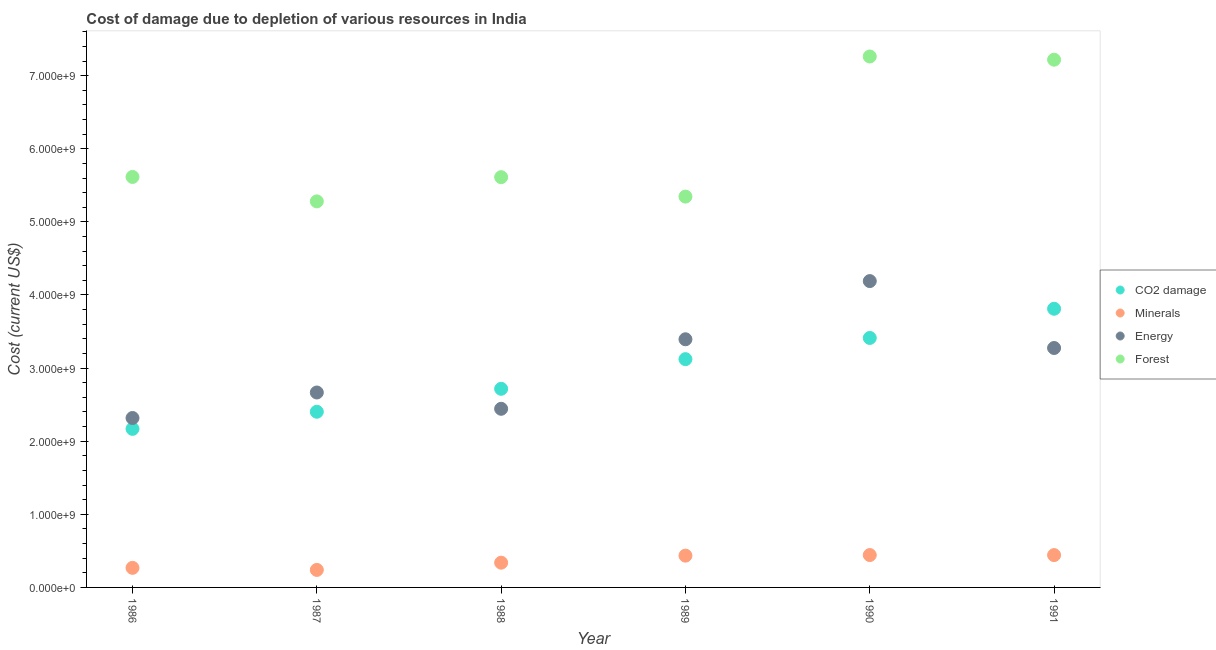What is the cost of damage due to depletion of coal in 1991?
Provide a short and direct response. 3.81e+09. Across all years, what is the maximum cost of damage due to depletion of coal?
Make the answer very short. 3.81e+09. Across all years, what is the minimum cost of damage due to depletion of forests?
Make the answer very short. 5.28e+09. In which year was the cost of damage due to depletion of coal minimum?
Make the answer very short. 1986. What is the total cost of damage due to depletion of energy in the graph?
Ensure brevity in your answer.  1.83e+1. What is the difference between the cost of damage due to depletion of forests in 1986 and that in 1991?
Keep it short and to the point. -1.60e+09. What is the difference between the cost of damage due to depletion of forests in 1988 and the cost of damage due to depletion of energy in 1986?
Your answer should be compact. 3.29e+09. What is the average cost of damage due to depletion of forests per year?
Provide a succinct answer. 6.06e+09. In the year 1991, what is the difference between the cost of damage due to depletion of forests and cost of damage due to depletion of minerals?
Make the answer very short. 6.78e+09. What is the ratio of the cost of damage due to depletion of forests in 1986 to that in 1990?
Provide a short and direct response. 0.77. What is the difference between the highest and the second highest cost of damage due to depletion of coal?
Offer a very short reply. 3.99e+08. What is the difference between the highest and the lowest cost of damage due to depletion of coal?
Provide a succinct answer. 1.64e+09. Is the sum of the cost of damage due to depletion of energy in 1987 and 1991 greater than the maximum cost of damage due to depletion of forests across all years?
Your answer should be compact. No. Is it the case that in every year, the sum of the cost of damage due to depletion of coal and cost of damage due to depletion of energy is greater than the sum of cost of damage due to depletion of minerals and cost of damage due to depletion of forests?
Provide a short and direct response. Yes. Does the cost of damage due to depletion of minerals monotonically increase over the years?
Give a very brief answer. No. How many years are there in the graph?
Ensure brevity in your answer.  6. What is the difference between two consecutive major ticks on the Y-axis?
Offer a terse response. 1.00e+09. Does the graph contain grids?
Provide a short and direct response. No. Where does the legend appear in the graph?
Offer a terse response. Center right. What is the title of the graph?
Ensure brevity in your answer.  Cost of damage due to depletion of various resources in India . Does "Miscellaneous expenses" appear as one of the legend labels in the graph?
Your response must be concise. No. What is the label or title of the Y-axis?
Provide a succinct answer. Cost (current US$). What is the Cost (current US$) of CO2 damage in 1986?
Your answer should be compact. 2.17e+09. What is the Cost (current US$) of Minerals in 1986?
Your answer should be very brief. 2.68e+08. What is the Cost (current US$) of Energy in 1986?
Make the answer very short. 2.32e+09. What is the Cost (current US$) in Forest in 1986?
Ensure brevity in your answer.  5.61e+09. What is the Cost (current US$) of CO2 damage in 1987?
Make the answer very short. 2.40e+09. What is the Cost (current US$) in Minerals in 1987?
Your answer should be compact. 2.40e+08. What is the Cost (current US$) of Energy in 1987?
Offer a very short reply. 2.67e+09. What is the Cost (current US$) in Forest in 1987?
Your response must be concise. 5.28e+09. What is the Cost (current US$) in CO2 damage in 1988?
Offer a very short reply. 2.72e+09. What is the Cost (current US$) of Minerals in 1988?
Ensure brevity in your answer.  3.38e+08. What is the Cost (current US$) in Energy in 1988?
Give a very brief answer. 2.44e+09. What is the Cost (current US$) of Forest in 1988?
Provide a short and direct response. 5.61e+09. What is the Cost (current US$) of CO2 damage in 1989?
Offer a very short reply. 3.12e+09. What is the Cost (current US$) of Minerals in 1989?
Offer a terse response. 4.35e+08. What is the Cost (current US$) of Energy in 1989?
Provide a short and direct response. 3.39e+09. What is the Cost (current US$) in Forest in 1989?
Give a very brief answer. 5.35e+09. What is the Cost (current US$) of CO2 damage in 1990?
Your response must be concise. 3.41e+09. What is the Cost (current US$) of Minerals in 1990?
Make the answer very short. 4.43e+08. What is the Cost (current US$) in Energy in 1990?
Provide a short and direct response. 4.19e+09. What is the Cost (current US$) in Forest in 1990?
Offer a terse response. 7.26e+09. What is the Cost (current US$) in CO2 damage in 1991?
Provide a succinct answer. 3.81e+09. What is the Cost (current US$) in Minerals in 1991?
Give a very brief answer. 4.42e+08. What is the Cost (current US$) of Energy in 1991?
Ensure brevity in your answer.  3.27e+09. What is the Cost (current US$) of Forest in 1991?
Provide a succinct answer. 7.22e+09. Across all years, what is the maximum Cost (current US$) of CO2 damage?
Keep it short and to the point. 3.81e+09. Across all years, what is the maximum Cost (current US$) of Minerals?
Offer a very short reply. 4.43e+08. Across all years, what is the maximum Cost (current US$) of Energy?
Your answer should be very brief. 4.19e+09. Across all years, what is the maximum Cost (current US$) of Forest?
Give a very brief answer. 7.26e+09. Across all years, what is the minimum Cost (current US$) of CO2 damage?
Make the answer very short. 2.17e+09. Across all years, what is the minimum Cost (current US$) of Minerals?
Offer a terse response. 2.40e+08. Across all years, what is the minimum Cost (current US$) in Energy?
Provide a short and direct response. 2.32e+09. Across all years, what is the minimum Cost (current US$) of Forest?
Your response must be concise. 5.28e+09. What is the total Cost (current US$) in CO2 damage in the graph?
Your answer should be compact. 1.76e+1. What is the total Cost (current US$) in Minerals in the graph?
Keep it short and to the point. 2.17e+09. What is the total Cost (current US$) in Energy in the graph?
Provide a short and direct response. 1.83e+1. What is the total Cost (current US$) in Forest in the graph?
Provide a short and direct response. 3.63e+1. What is the difference between the Cost (current US$) in CO2 damage in 1986 and that in 1987?
Give a very brief answer. -2.34e+08. What is the difference between the Cost (current US$) in Minerals in 1986 and that in 1987?
Provide a short and direct response. 2.81e+07. What is the difference between the Cost (current US$) in Energy in 1986 and that in 1987?
Keep it short and to the point. -3.49e+08. What is the difference between the Cost (current US$) in Forest in 1986 and that in 1987?
Offer a terse response. 3.34e+08. What is the difference between the Cost (current US$) of CO2 damage in 1986 and that in 1988?
Offer a very short reply. -5.48e+08. What is the difference between the Cost (current US$) of Minerals in 1986 and that in 1988?
Keep it short and to the point. -7.08e+07. What is the difference between the Cost (current US$) in Energy in 1986 and that in 1988?
Keep it short and to the point. -1.26e+08. What is the difference between the Cost (current US$) in Forest in 1986 and that in 1988?
Offer a very short reply. 2.98e+06. What is the difference between the Cost (current US$) in CO2 damage in 1986 and that in 1989?
Provide a succinct answer. -9.54e+08. What is the difference between the Cost (current US$) of Minerals in 1986 and that in 1989?
Give a very brief answer. -1.67e+08. What is the difference between the Cost (current US$) in Energy in 1986 and that in 1989?
Provide a succinct answer. -1.08e+09. What is the difference between the Cost (current US$) of Forest in 1986 and that in 1989?
Ensure brevity in your answer.  2.69e+08. What is the difference between the Cost (current US$) of CO2 damage in 1986 and that in 1990?
Your answer should be compact. -1.24e+09. What is the difference between the Cost (current US$) of Minerals in 1986 and that in 1990?
Offer a terse response. -1.75e+08. What is the difference between the Cost (current US$) of Energy in 1986 and that in 1990?
Give a very brief answer. -1.87e+09. What is the difference between the Cost (current US$) in Forest in 1986 and that in 1990?
Your answer should be compact. -1.65e+09. What is the difference between the Cost (current US$) of CO2 damage in 1986 and that in 1991?
Offer a terse response. -1.64e+09. What is the difference between the Cost (current US$) in Minerals in 1986 and that in 1991?
Offer a very short reply. -1.75e+08. What is the difference between the Cost (current US$) of Energy in 1986 and that in 1991?
Ensure brevity in your answer.  -9.57e+08. What is the difference between the Cost (current US$) of Forest in 1986 and that in 1991?
Your response must be concise. -1.60e+09. What is the difference between the Cost (current US$) of CO2 damage in 1987 and that in 1988?
Make the answer very short. -3.14e+08. What is the difference between the Cost (current US$) of Minerals in 1987 and that in 1988?
Your answer should be very brief. -9.89e+07. What is the difference between the Cost (current US$) of Energy in 1987 and that in 1988?
Provide a succinct answer. 2.23e+08. What is the difference between the Cost (current US$) in Forest in 1987 and that in 1988?
Your answer should be compact. -3.31e+08. What is the difference between the Cost (current US$) in CO2 damage in 1987 and that in 1989?
Give a very brief answer. -7.19e+08. What is the difference between the Cost (current US$) in Minerals in 1987 and that in 1989?
Your answer should be very brief. -1.95e+08. What is the difference between the Cost (current US$) of Energy in 1987 and that in 1989?
Provide a short and direct response. -7.28e+08. What is the difference between the Cost (current US$) of Forest in 1987 and that in 1989?
Your answer should be very brief. -6.53e+07. What is the difference between the Cost (current US$) of CO2 damage in 1987 and that in 1990?
Offer a terse response. -1.01e+09. What is the difference between the Cost (current US$) in Minerals in 1987 and that in 1990?
Provide a short and direct response. -2.03e+08. What is the difference between the Cost (current US$) of Energy in 1987 and that in 1990?
Your response must be concise. -1.52e+09. What is the difference between the Cost (current US$) in Forest in 1987 and that in 1990?
Offer a terse response. -1.98e+09. What is the difference between the Cost (current US$) of CO2 damage in 1987 and that in 1991?
Give a very brief answer. -1.41e+09. What is the difference between the Cost (current US$) in Minerals in 1987 and that in 1991?
Your answer should be very brief. -2.03e+08. What is the difference between the Cost (current US$) in Energy in 1987 and that in 1991?
Your response must be concise. -6.09e+08. What is the difference between the Cost (current US$) in Forest in 1987 and that in 1991?
Offer a terse response. -1.94e+09. What is the difference between the Cost (current US$) of CO2 damage in 1988 and that in 1989?
Your answer should be compact. -4.06e+08. What is the difference between the Cost (current US$) in Minerals in 1988 and that in 1989?
Provide a short and direct response. -9.62e+07. What is the difference between the Cost (current US$) in Energy in 1988 and that in 1989?
Offer a terse response. -9.51e+08. What is the difference between the Cost (current US$) of Forest in 1988 and that in 1989?
Your response must be concise. 2.66e+08. What is the difference between the Cost (current US$) in CO2 damage in 1988 and that in 1990?
Ensure brevity in your answer.  -6.96e+08. What is the difference between the Cost (current US$) of Minerals in 1988 and that in 1990?
Offer a terse response. -1.04e+08. What is the difference between the Cost (current US$) of Energy in 1988 and that in 1990?
Make the answer very short. -1.75e+09. What is the difference between the Cost (current US$) of Forest in 1988 and that in 1990?
Your answer should be compact. -1.65e+09. What is the difference between the Cost (current US$) in CO2 damage in 1988 and that in 1991?
Give a very brief answer. -1.09e+09. What is the difference between the Cost (current US$) of Minerals in 1988 and that in 1991?
Make the answer very short. -1.04e+08. What is the difference between the Cost (current US$) of Energy in 1988 and that in 1991?
Provide a short and direct response. -8.32e+08. What is the difference between the Cost (current US$) in Forest in 1988 and that in 1991?
Ensure brevity in your answer.  -1.61e+09. What is the difference between the Cost (current US$) of CO2 damage in 1989 and that in 1990?
Keep it short and to the point. -2.90e+08. What is the difference between the Cost (current US$) in Minerals in 1989 and that in 1990?
Your response must be concise. -8.24e+06. What is the difference between the Cost (current US$) of Energy in 1989 and that in 1990?
Your response must be concise. -7.96e+08. What is the difference between the Cost (current US$) of Forest in 1989 and that in 1990?
Your answer should be compact. -1.92e+09. What is the difference between the Cost (current US$) in CO2 damage in 1989 and that in 1991?
Your answer should be compact. -6.89e+08. What is the difference between the Cost (current US$) of Minerals in 1989 and that in 1991?
Give a very brief answer. -7.56e+06. What is the difference between the Cost (current US$) of Energy in 1989 and that in 1991?
Keep it short and to the point. 1.19e+08. What is the difference between the Cost (current US$) in Forest in 1989 and that in 1991?
Your response must be concise. -1.87e+09. What is the difference between the Cost (current US$) of CO2 damage in 1990 and that in 1991?
Give a very brief answer. -3.99e+08. What is the difference between the Cost (current US$) of Minerals in 1990 and that in 1991?
Your answer should be very brief. 6.78e+05. What is the difference between the Cost (current US$) in Energy in 1990 and that in 1991?
Your answer should be very brief. 9.15e+08. What is the difference between the Cost (current US$) in Forest in 1990 and that in 1991?
Ensure brevity in your answer.  4.38e+07. What is the difference between the Cost (current US$) of CO2 damage in 1986 and the Cost (current US$) of Minerals in 1987?
Make the answer very short. 1.93e+09. What is the difference between the Cost (current US$) of CO2 damage in 1986 and the Cost (current US$) of Energy in 1987?
Your response must be concise. -4.97e+08. What is the difference between the Cost (current US$) of CO2 damage in 1986 and the Cost (current US$) of Forest in 1987?
Your response must be concise. -3.11e+09. What is the difference between the Cost (current US$) of Minerals in 1986 and the Cost (current US$) of Energy in 1987?
Provide a succinct answer. -2.40e+09. What is the difference between the Cost (current US$) in Minerals in 1986 and the Cost (current US$) in Forest in 1987?
Give a very brief answer. -5.01e+09. What is the difference between the Cost (current US$) of Energy in 1986 and the Cost (current US$) of Forest in 1987?
Your answer should be very brief. -2.96e+09. What is the difference between the Cost (current US$) of CO2 damage in 1986 and the Cost (current US$) of Minerals in 1988?
Your answer should be very brief. 1.83e+09. What is the difference between the Cost (current US$) in CO2 damage in 1986 and the Cost (current US$) in Energy in 1988?
Give a very brief answer. -2.75e+08. What is the difference between the Cost (current US$) in CO2 damage in 1986 and the Cost (current US$) in Forest in 1988?
Your response must be concise. -3.44e+09. What is the difference between the Cost (current US$) of Minerals in 1986 and the Cost (current US$) of Energy in 1988?
Your answer should be compact. -2.18e+09. What is the difference between the Cost (current US$) in Minerals in 1986 and the Cost (current US$) in Forest in 1988?
Offer a very short reply. -5.34e+09. What is the difference between the Cost (current US$) of Energy in 1986 and the Cost (current US$) of Forest in 1988?
Your answer should be compact. -3.29e+09. What is the difference between the Cost (current US$) of CO2 damage in 1986 and the Cost (current US$) of Minerals in 1989?
Provide a succinct answer. 1.73e+09. What is the difference between the Cost (current US$) of CO2 damage in 1986 and the Cost (current US$) of Energy in 1989?
Provide a short and direct response. -1.23e+09. What is the difference between the Cost (current US$) of CO2 damage in 1986 and the Cost (current US$) of Forest in 1989?
Offer a terse response. -3.18e+09. What is the difference between the Cost (current US$) of Minerals in 1986 and the Cost (current US$) of Energy in 1989?
Your answer should be compact. -3.13e+09. What is the difference between the Cost (current US$) in Minerals in 1986 and the Cost (current US$) in Forest in 1989?
Your answer should be very brief. -5.08e+09. What is the difference between the Cost (current US$) in Energy in 1986 and the Cost (current US$) in Forest in 1989?
Your response must be concise. -3.03e+09. What is the difference between the Cost (current US$) in CO2 damage in 1986 and the Cost (current US$) in Minerals in 1990?
Your answer should be compact. 1.73e+09. What is the difference between the Cost (current US$) in CO2 damage in 1986 and the Cost (current US$) in Energy in 1990?
Offer a very short reply. -2.02e+09. What is the difference between the Cost (current US$) in CO2 damage in 1986 and the Cost (current US$) in Forest in 1990?
Offer a terse response. -5.09e+09. What is the difference between the Cost (current US$) in Minerals in 1986 and the Cost (current US$) in Energy in 1990?
Ensure brevity in your answer.  -3.92e+09. What is the difference between the Cost (current US$) of Minerals in 1986 and the Cost (current US$) of Forest in 1990?
Your answer should be very brief. -6.99e+09. What is the difference between the Cost (current US$) in Energy in 1986 and the Cost (current US$) in Forest in 1990?
Offer a very short reply. -4.94e+09. What is the difference between the Cost (current US$) in CO2 damage in 1986 and the Cost (current US$) in Minerals in 1991?
Provide a short and direct response. 1.73e+09. What is the difference between the Cost (current US$) of CO2 damage in 1986 and the Cost (current US$) of Energy in 1991?
Provide a short and direct response. -1.11e+09. What is the difference between the Cost (current US$) in CO2 damage in 1986 and the Cost (current US$) in Forest in 1991?
Provide a short and direct response. -5.05e+09. What is the difference between the Cost (current US$) in Minerals in 1986 and the Cost (current US$) in Energy in 1991?
Make the answer very short. -3.01e+09. What is the difference between the Cost (current US$) in Minerals in 1986 and the Cost (current US$) in Forest in 1991?
Make the answer very short. -6.95e+09. What is the difference between the Cost (current US$) in Energy in 1986 and the Cost (current US$) in Forest in 1991?
Your response must be concise. -4.90e+09. What is the difference between the Cost (current US$) in CO2 damage in 1987 and the Cost (current US$) in Minerals in 1988?
Your answer should be compact. 2.06e+09. What is the difference between the Cost (current US$) of CO2 damage in 1987 and the Cost (current US$) of Energy in 1988?
Provide a succinct answer. -4.05e+07. What is the difference between the Cost (current US$) in CO2 damage in 1987 and the Cost (current US$) in Forest in 1988?
Keep it short and to the point. -3.21e+09. What is the difference between the Cost (current US$) of Minerals in 1987 and the Cost (current US$) of Energy in 1988?
Give a very brief answer. -2.20e+09. What is the difference between the Cost (current US$) in Minerals in 1987 and the Cost (current US$) in Forest in 1988?
Provide a short and direct response. -5.37e+09. What is the difference between the Cost (current US$) of Energy in 1987 and the Cost (current US$) of Forest in 1988?
Your answer should be very brief. -2.95e+09. What is the difference between the Cost (current US$) of CO2 damage in 1987 and the Cost (current US$) of Minerals in 1989?
Provide a succinct answer. 1.97e+09. What is the difference between the Cost (current US$) in CO2 damage in 1987 and the Cost (current US$) in Energy in 1989?
Keep it short and to the point. -9.91e+08. What is the difference between the Cost (current US$) in CO2 damage in 1987 and the Cost (current US$) in Forest in 1989?
Offer a very short reply. -2.94e+09. What is the difference between the Cost (current US$) of Minerals in 1987 and the Cost (current US$) of Energy in 1989?
Offer a terse response. -3.15e+09. What is the difference between the Cost (current US$) of Minerals in 1987 and the Cost (current US$) of Forest in 1989?
Ensure brevity in your answer.  -5.11e+09. What is the difference between the Cost (current US$) of Energy in 1987 and the Cost (current US$) of Forest in 1989?
Provide a succinct answer. -2.68e+09. What is the difference between the Cost (current US$) of CO2 damage in 1987 and the Cost (current US$) of Minerals in 1990?
Give a very brief answer. 1.96e+09. What is the difference between the Cost (current US$) in CO2 damage in 1987 and the Cost (current US$) in Energy in 1990?
Your answer should be compact. -1.79e+09. What is the difference between the Cost (current US$) of CO2 damage in 1987 and the Cost (current US$) of Forest in 1990?
Provide a short and direct response. -4.86e+09. What is the difference between the Cost (current US$) of Minerals in 1987 and the Cost (current US$) of Energy in 1990?
Make the answer very short. -3.95e+09. What is the difference between the Cost (current US$) in Minerals in 1987 and the Cost (current US$) in Forest in 1990?
Make the answer very short. -7.02e+09. What is the difference between the Cost (current US$) in Energy in 1987 and the Cost (current US$) in Forest in 1990?
Keep it short and to the point. -4.60e+09. What is the difference between the Cost (current US$) in CO2 damage in 1987 and the Cost (current US$) in Minerals in 1991?
Provide a succinct answer. 1.96e+09. What is the difference between the Cost (current US$) of CO2 damage in 1987 and the Cost (current US$) of Energy in 1991?
Your answer should be compact. -8.72e+08. What is the difference between the Cost (current US$) in CO2 damage in 1987 and the Cost (current US$) in Forest in 1991?
Your answer should be very brief. -4.82e+09. What is the difference between the Cost (current US$) of Minerals in 1987 and the Cost (current US$) of Energy in 1991?
Provide a succinct answer. -3.04e+09. What is the difference between the Cost (current US$) in Minerals in 1987 and the Cost (current US$) in Forest in 1991?
Your response must be concise. -6.98e+09. What is the difference between the Cost (current US$) in Energy in 1987 and the Cost (current US$) in Forest in 1991?
Provide a succinct answer. -4.55e+09. What is the difference between the Cost (current US$) of CO2 damage in 1988 and the Cost (current US$) of Minerals in 1989?
Keep it short and to the point. 2.28e+09. What is the difference between the Cost (current US$) in CO2 damage in 1988 and the Cost (current US$) in Energy in 1989?
Your answer should be compact. -6.77e+08. What is the difference between the Cost (current US$) of CO2 damage in 1988 and the Cost (current US$) of Forest in 1989?
Make the answer very short. -2.63e+09. What is the difference between the Cost (current US$) of Minerals in 1988 and the Cost (current US$) of Energy in 1989?
Your answer should be compact. -3.06e+09. What is the difference between the Cost (current US$) in Minerals in 1988 and the Cost (current US$) in Forest in 1989?
Provide a short and direct response. -5.01e+09. What is the difference between the Cost (current US$) in Energy in 1988 and the Cost (current US$) in Forest in 1989?
Keep it short and to the point. -2.90e+09. What is the difference between the Cost (current US$) of CO2 damage in 1988 and the Cost (current US$) of Minerals in 1990?
Offer a terse response. 2.27e+09. What is the difference between the Cost (current US$) in CO2 damage in 1988 and the Cost (current US$) in Energy in 1990?
Ensure brevity in your answer.  -1.47e+09. What is the difference between the Cost (current US$) of CO2 damage in 1988 and the Cost (current US$) of Forest in 1990?
Give a very brief answer. -4.55e+09. What is the difference between the Cost (current US$) of Minerals in 1988 and the Cost (current US$) of Energy in 1990?
Your answer should be very brief. -3.85e+09. What is the difference between the Cost (current US$) of Minerals in 1988 and the Cost (current US$) of Forest in 1990?
Your answer should be compact. -6.92e+09. What is the difference between the Cost (current US$) in Energy in 1988 and the Cost (current US$) in Forest in 1990?
Give a very brief answer. -4.82e+09. What is the difference between the Cost (current US$) in CO2 damage in 1988 and the Cost (current US$) in Minerals in 1991?
Provide a succinct answer. 2.27e+09. What is the difference between the Cost (current US$) of CO2 damage in 1988 and the Cost (current US$) of Energy in 1991?
Ensure brevity in your answer.  -5.58e+08. What is the difference between the Cost (current US$) of CO2 damage in 1988 and the Cost (current US$) of Forest in 1991?
Offer a very short reply. -4.50e+09. What is the difference between the Cost (current US$) in Minerals in 1988 and the Cost (current US$) in Energy in 1991?
Your answer should be very brief. -2.94e+09. What is the difference between the Cost (current US$) of Minerals in 1988 and the Cost (current US$) of Forest in 1991?
Make the answer very short. -6.88e+09. What is the difference between the Cost (current US$) in Energy in 1988 and the Cost (current US$) in Forest in 1991?
Give a very brief answer. -4.77e+09. What is the difference between the Cost (current US$) of CO2 damage in 1989 and the Cost (current US$) of Minerals in 1990?
Offer a terse response. 2.68e+09. What is the difference between the Cost (current US$) of CO2 damage in 1989 and the Cost (current US$) of Energy in 1990?
Keep it short and to the point. -1.07e+09. What is the difference between the Cost (current US$) of CO2 damage in 1989 and the Cost (current US$) of Forest in 1990?
Your answer should be very brief. -4.14e+09. What is the difference between the Cost (current US$) of Minerals in 1989 and the Cost (current US$) of Energy in 1990?
Provide a succinct answer. -3.76e+09. What is the difference between the Cost (current US$) of Minerals in 1989 and the Cost (current US$) of Forest in 1990?
Offer a terse response. -6.83e+09. What is the difference between the Cost (current US$) of Energy in 1989 and the Cost (current US$) of Forest in 1990?
Your answer should be compact. -3.87e+09. What is the difference between the Cost (current US$) of CO2 damage in 1989 and the Cost (current US$) of Minerals in 1991?
Offer a very short reply. 2.68e+09. What is the difference between the Cost (current US$) in CO2 damage in 1989 and the Cost (current US$) in Energy in 1991?
Ensure brevity in your answer.  -1.53e+08. What is the difference between the Cost (current US$) of CO2 damage in 1989 and the Cost (current US$) of Forest in 1991?
Ensure brevity in your answer.  -4.10e+09. What is the difference between the Cost (current US$) in Minerals in 1989 and the Cost (current US$) in Energy in 1991?
Make the answer very short. -2.84e+09. What is the difference between the Cost (current US$) of Minerals in 1989 and the Cost (current US$) of Forest in 1991?
Ensure brevity in your answer.  -6.78e+09. What is the difference between the Cost (current US$) of Energy in 1989 and the Cost (current US$) of Forest in 1991?
Your answer should be compact. -3.82e+09. What is the difference between the Cost (current US$) of CO2 damage in 1990 and the Cost (current US$) of Minerals in 1991?
Your response must be concise. 2.97e+09. What is the difference between the Cost (current US$) of CO2 damage in 1990 and the Cost (current US$) of Energy in 1991?
Offer a very short reply. 1.37e+08. What is the difference between the Cost (current US$) of CO2 damage in 1990 and the Cost (current US$) of Forest in 1991?
Your answer should be very brief. -3.81e+09. What is the difference between the Cost (current US$) of Minerals in 1990 and the Cost (current US$) of Energy in 1991?
Make the answer very short. -2.83e+09. What is the difference between the Cost (current US$) of Minerals in 1990 and the Cost (current US$) of Forest in 1991?
Provide a short and direct response. -6.78e+09. What is the difference between the Cost (current US$) in Energy in 1990 and the Cost (current US$) in Forest in 1991?
Offer a very short reply. -3.03e+09. What is the average Cost (current US$) in CO2 damage per year?
Your answer should be compact. 2.94e+09. What is the average Cost (current US$) in Minerals per year?
Give a very brief answer. 3.61e+08. What is the average Cost (current US$) of Energy per year?
Offer a terse response. 3.05e+09. What is the average Cost (current US$) in Forest per year?
Provide a short and direct response. 6.06e+09. In the year 1986, what is the difference between the Cost (current US$) in CO2 damage and Cost (current US$) in Minerals?
Offer a very short reply. 1.90e+09. In the year 1986, what is the difference between the Cost (current US$) in CO2 damage and Cost (current US$) in Energy?
Give a very brief answer. -1.49e+08. In the year 1986, what is the difference between the Cost (current US$) in CO2 damage and Cost (current US$) in Forest?
Keep it short and to the point. -3.45e+09. In the year 1986, what is the difference between the Cost (current US$) in Minerals and Cost (current US$) in Energy?
Your answer should be compact. -2.05e+09. In the year 1986, what is the difference between the Cost (current US$) in Minerals and Cost (current US$) in Forest?
Offer a very short reply. -5.35e+09. In the year 1986, what is the difference between the Cost (current US$) in Energy and Cost (current US$) in Forest?
Provide a succinct answer. -3.30e+09. In the year 1987, what is the difference between the Cost (current US$) of CO2 damage and Cost (current US$) of Minerals?
Provide a succinct answer. 2.16e+09. In the year 1987, what is the difference between the Cost (current US$) in CO2 damage and Cost (current US$) in Energy?
Make the answer very short. -2.63e+08. In the year 1987, what is the difference between the Cost (current US$) of CO2 damage and Cost (current US$) of Forest?
Make the answer very short. -2.88e+09. In the year 1987, what is the difference between the Cost (current US$) in Minerals and Cost (current US$) in Energy?
Provide a succinct answer. -2.43e+09. In the year 1987, what is the difference between the Cost (current US$) in Minerals and Cost (current US$) in Forest?
Provide a short and direct response. -5.04e+09. In the year 1987, what is the difference between the Cost (current US$) in Energy and Cost (current US$) in Forest?
Offer a terse response. -2.61e+09. In the year 1988, what is the difference between the Cost (current US$) in CO2 damage and Cost (current US$) in Minerals?
Make the answer very short. 2.38e+09. In the year 1988, what is the difference between the Cost (current US$) of CO2 damage and Cost (current US$) of Energy?
Provide a succinct answer. 2.73e+08. In the year 1988, what is the difference between the Cost (current US$) of CO2 damage and Cost (current US$) of Forest?
Give a very brief answer. -2.89e+09. In the year 1988, what is the difference between the Cost (current US$) in Minerals and Cost (current US$) in Energy?
Your response must be concise. -2.10e+09. In the year 1988, what is the difference between the Cost (current US$) in Minerals and Cost (current US$) in Forest?
Provide a succinct answer. -5.27e+09. In the year 1988, what is the difference between the Cost (current US$) of Energy and Cost (current US$) of Forest?
Offer a terse response. -3.17e+09. In the year 1989, what is the difference between the Cost (current US$) of CO2 damage and Cost (current US$) of Minerals?
Ensure brevity in your answer.  2.69e+09. In the year 1989, what is the difference between the Cost (current US$) of CO2 damage and Cost (current US$) of Energy?
Your answer should be compact. -2.72e+08. In the year 1989, what is the difference between the Cost (current US$) of CO2 damage and Cost (current US$) of Forest?
Your response must be concise. -2.22e+09. In the year 1989, what is the difference between the Cost (current US$) of Minerals and Cost (current US$) of Energy?
Ensure brevity in your answer.  -2.96e+09. In the year 1989, what is the difference between the Cost (current US$) of Minerals and Cost (current US$) of Forest?
Ensure brevity in your answer.  -4.91e+09. In the year 1989, what is the difference between the Cost (current US$) in Energy and Cost (current US$) in Forest?
Your answer should be compact. -1.95e+09. In the year 1990, what is the difference between the Cost (current US$) of CO2 damage and Cost (current US$) of Minerals?
Your answer should be very brief. 2.97e+09. In the year 1990, what is the difference between the Cost (current US$) of CO2 damage and Cost (current US$) of Energy?
Your response must be concise. -7.78e+08. In the year 1990, what is the difference between the Cost (current US$) of CO2 damage and Cost (current US$) of Forest?
Offer a very short reply. -3.85e+09. In the year 1990, what is the difference between the Cost (current US$) of Minerals and Cost (current US$) of Energy?
Make the answer very short. -3.75e+09. In the year 1990, what is the difference between the Cost (current US$) of Minerals and Cost (current US$) of Forest?
Offer a very short reply. -6.82e+09. In the year 1990, what is the difference between the Cost (current US$) of Energy and Cost (current US$) of Forest?
Your response must be concise. -3.07e+09. In the year 1991, what is the difference between the Cost (current US$) of CO2 damage and Cost (current US$) of Minerals?
Your answer should be very brief. 3.37e+09. In the year 1991, what is the difference between the Cost (current US$) in CO2 damage and Cost (current US$) in Energy?
Your response must be concise. 5.37e+08. In the year 1991, what is the difference between the Cost (current US$) of CO2 damage and Cost (current US$) of Forest?
Your answer should be very brief. -3.41e+09. In the year 1991, what is the difference between the Cost (current US$) in Minerals and Cost (current US$) in Energy?
Your answer should be compact. -2.83e+09. In the year 1991, what is the difference between the Cost (current US$) of Minerals and Cost (current US$) of Forest?
Provide a short and direct response. -6.78e+09. In the year 1991, what is the difference between the Cost (current US$) of Energy and Cost (current US$) of Forest?
Give a very brief answer. -3.94e+09. What is the ratio of the Cost (current US$) in CO2 damage in 1986 to that in 1987?
Make the answer very short. 0.9. What is the ratio of the Cost (current US$) in Minerals in 1986 to that in 1987?
Ensure brevity in your answer.  1.12. What is the ratio of the Cost (current US$) in Energy in 1986 to that in 1987?
Offer a very short reply. 0.87. What is the ratio of the Cost (current US$) of Forest in 1986 to that in 1987?
Your answer should be very brief. 1.06. What is the ratio of the Cost (current US$) in CO2 damage in 1986 to that in 1988?
Your response must be concise. 0.8. What is the ratio of the Cost (current US$) in Minerals in 1986 to that in 1988?
Keep it short and to the point. 0.79. What is the ratio of the Cost (current US$) of Energy in 1986 to that in 1988?
Offer a very short reply. 0.95. What is the ratio of the Cost (current US$) of CO2 damage in 1986 to that in 1989?
Make the answer very short. 0.69. What is the ratio of the Cost (current US$) of Minerals in 1986 to that in 1989?
Your answer should be compact. 0.62. What is the ratio of the Cost (current US$) of Energy in 1986 to that in 1989?
Offer a very short reply. 0.68. What is the ratio of the Cost (current US$) of Forest in 1986 to that in 1989?
Provide a succinct answer. 1.05. What is the ratio of the Cost (current US$) of CO2 damage in 1986 to that in 1990?
Provide a short and direct response. 0.64. What is the ratio of the Cost (current US$) in Minerals in 1986 to that in 1990?
Your answer should be compact. 0.6. What is the ratio of the Cost (current US$) of Energy in 1986 to that in 1990?
Make the answer very short. 0.55. What is the ratio of the Cost (current US$) in Forest in 1986 to that in 1990?
Provide a short and direct response. 0.77. What is the ratio of the Cost (current US$) in CO2 damage in 1986 to that in 1991?
Offer a terse response. 0.57. What is the ratio of the Cost (current US$) of Minerals in 1986 to that in 1991?
Offer a terse response. 0.61. What is the ratio of the Cost (current US$) of Energy in 1986 to that in 1991?
Make the answer very short. 0.71. What is the ratio of the Cost (current US$) in Forest in 1986 to that in 1991?
Make the answer very short. 0.78. What is the ratio of the Cost (current US$) in CO2 damage in 1987 to that in 1988?
Ensure brevity in your answer.  0.88. What is the ratio of the Cost (current US$) in Minerals in 1987 to that in 1988?
Give a very brief answer. 0.71. What is the ratio of the Cost (current US$) of Energy in 1987 to that in 1988?
Provide a succinct answer. 1.09. What is the ratio of the Cost (current US$) in Forest in 1987 to that in 1988?
Ensure brevity in your answer.  0.94. What is the ratio of the Cost (current US$) of CO2 damage in 1987 to that in 1989?
Offer a very short reply. 0.77. What is the ratio of the Cost (current US$) in Minerals in 1987 to that in 1989?
Offer a very short reply. 0.55. What is the ratio of the Cost (current US$) in Energy in 1987 to that in 1989?
Your answer should be very brief. 0.79. What is the ratio of the Cost (current US$) of CO2 damage in 1987 to that in 1990?
Offer a very short reply. 0.7. What is the ratio of the Cost (current US$) of Minerals in 1987 to that in 1990?
Make the answer very short. 0.54. What is the ratio of the Cost (current US$) of Energy in 1987 to that in 1990?
Provide a short and direct response. 0.64. What is the ratio of the Cost (current US$) of Forest in 1987 to that in 1990?
Provide a short and direct response. 0.73. What is the ratio of the Cost (current US$) of CO2 damage in 1987 to that in 1991?
Your answer should be very brief. 0.63. What is the ratio of the Cost (current US$) in Minerals in 1987 to that in 1991?
Your answer should be very brief. 0.54. What is the ratio of the Cost (current US$) of Energy in 1987 to that in 1991?
Offer a very short reply. 0.81. What is the ratio of the Cost (current US$) in Forest in 1987 to that in 1991?
Your response must be concise. 0.73. What is the ratio of the Cost (current US$) in CO2 damage in 1988 to that in 1989?
Your answer should be very brief. 0.87. What is the ratio of the Cost (current US$) of Minerals in 1988 to that in 1989?
Your answer should be very brief. 0.78. What is the ratio of the Cost (current US$) in Energy in 1988 to that in 1989?
Your response must be concise. 0.72. What is the ratio of the Cost (current US$) of Forest in 1988 to that in 1989?
Give a very brief answer. 1.05. What is the ratio of the Cost (current US$) of CO2 damage in 1988 to that in 1990?
Offer a terse response. 0.8. What is the ratio of the Cost (current US$) in Minerals in 1988 to that in 1990?
Offer a terse response. 0.76. What is the ratio of the Cost (current US$) in Energy in 1988 to that in 1990?
Offer a very short reply. 0.58. What is the ratio of the Cost (current US$) of Forest in 1988 to that in 1990?
Offer a terse response. 0.77. What is the ratio of the Cost (current US$) in CO2 damage in 1988 to that in 1991?
Your answer should be compact. 0.71. What is the ratio of the Cost (current US$) in Minerals in 1988 to that in 1991?
Offer a terse response. 0.77. What is the ratio of the Cost (current US$) in Energy in 1988 to that in 1991?
Your answer should be compact. 0.75. What is the ratio of the Cost (current US$) of Forest in 1988 to that in 1991?
Your answer should be very brief. 0.78. What is the ratio of the Cost (current US$) in CO2 damage in 1989 to that in 1990?
Offer a terse response. 0.92. What is the ratio of the Cost (current US$) in Minerals in 1989 to that in 1990?
Your answer should be very brief. 0.98. What is the ratio of the Cost (current US$) in Energy in 1989 to that in 1990?
Your answer should be compact. 0.81. What is the ratio of the Cost (current US$) of Forest in 1989 to that in 1990?
Your response must be concise. 0.74. What is the ratio of the Cost (current US$) of CO2 damage in 1989 to that in 1991?
Your answer should be very brief. 0.82. What is the ratio of the Cost (current US$) in Minerals in 1989 to that in 1991?
Your answer should be compact. 0.98. What is the ratio of the Cost (current US$) in Energy in 1989 to that in 1991?
Provide a succinct answer. 1.04. What is the ratio of the Cost (current US$) of Forest in 1989 to that in 1991?
Your response must be concise. 0.74. What is the ratio of the Cost (current US$) in CO2 damage in 1990 to that in 1991?
Your response must be concise. 0.9. What is the ratio of the Cost (current US$) in Minerals in 1990 to that in 1991?
Give a very brief answer. 1. What is the ratio of the Cost (current US$) in Energy in 1990 to that in 1991?
Offer a terse response. 1.28. What is the difference between the highest and the second highest Cost (current US$) of CO2 damage?
Make the answer very short. 3.99e+08. What is the difference between the highest and the second highest Cost (current US$) of Minerals?
Keep it short and to the point. 6.78e+05. What is the difference between the highest and the second highest Cost (current US$) in Energy?
Your answer should be compact. 7.96e+08. What is the difference between the highest and the second highest Cost (current US$) in Forest?
Make the answer very short. 4.38e+07. What is the difference between the highest and the lowest Cost (current US$) of CO2 damage?
Offer a very short reply. 1.64e+09. What is the difference between the highest and the lowest Cost (current US$) in Minerals?
Provide a short and direct response. 2.03e+08. What is the difference between the highest and the lowest Cost (current US$) in Energy?
Keep it short and to the point. 1.87e+09. What is the difference between the highest and the lowest Cost (current US$) in Forest?
Offer a terse response. 1.98e+09. 